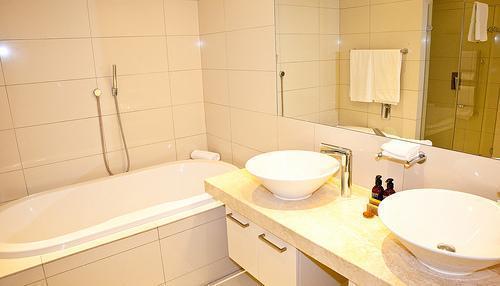How many sinks are there?
Give a very brief answer. 2. How many bathtubs are there?
Give a very brief answer. 1. How many bottles are on the counter?
Give a very brief answer. 2. 